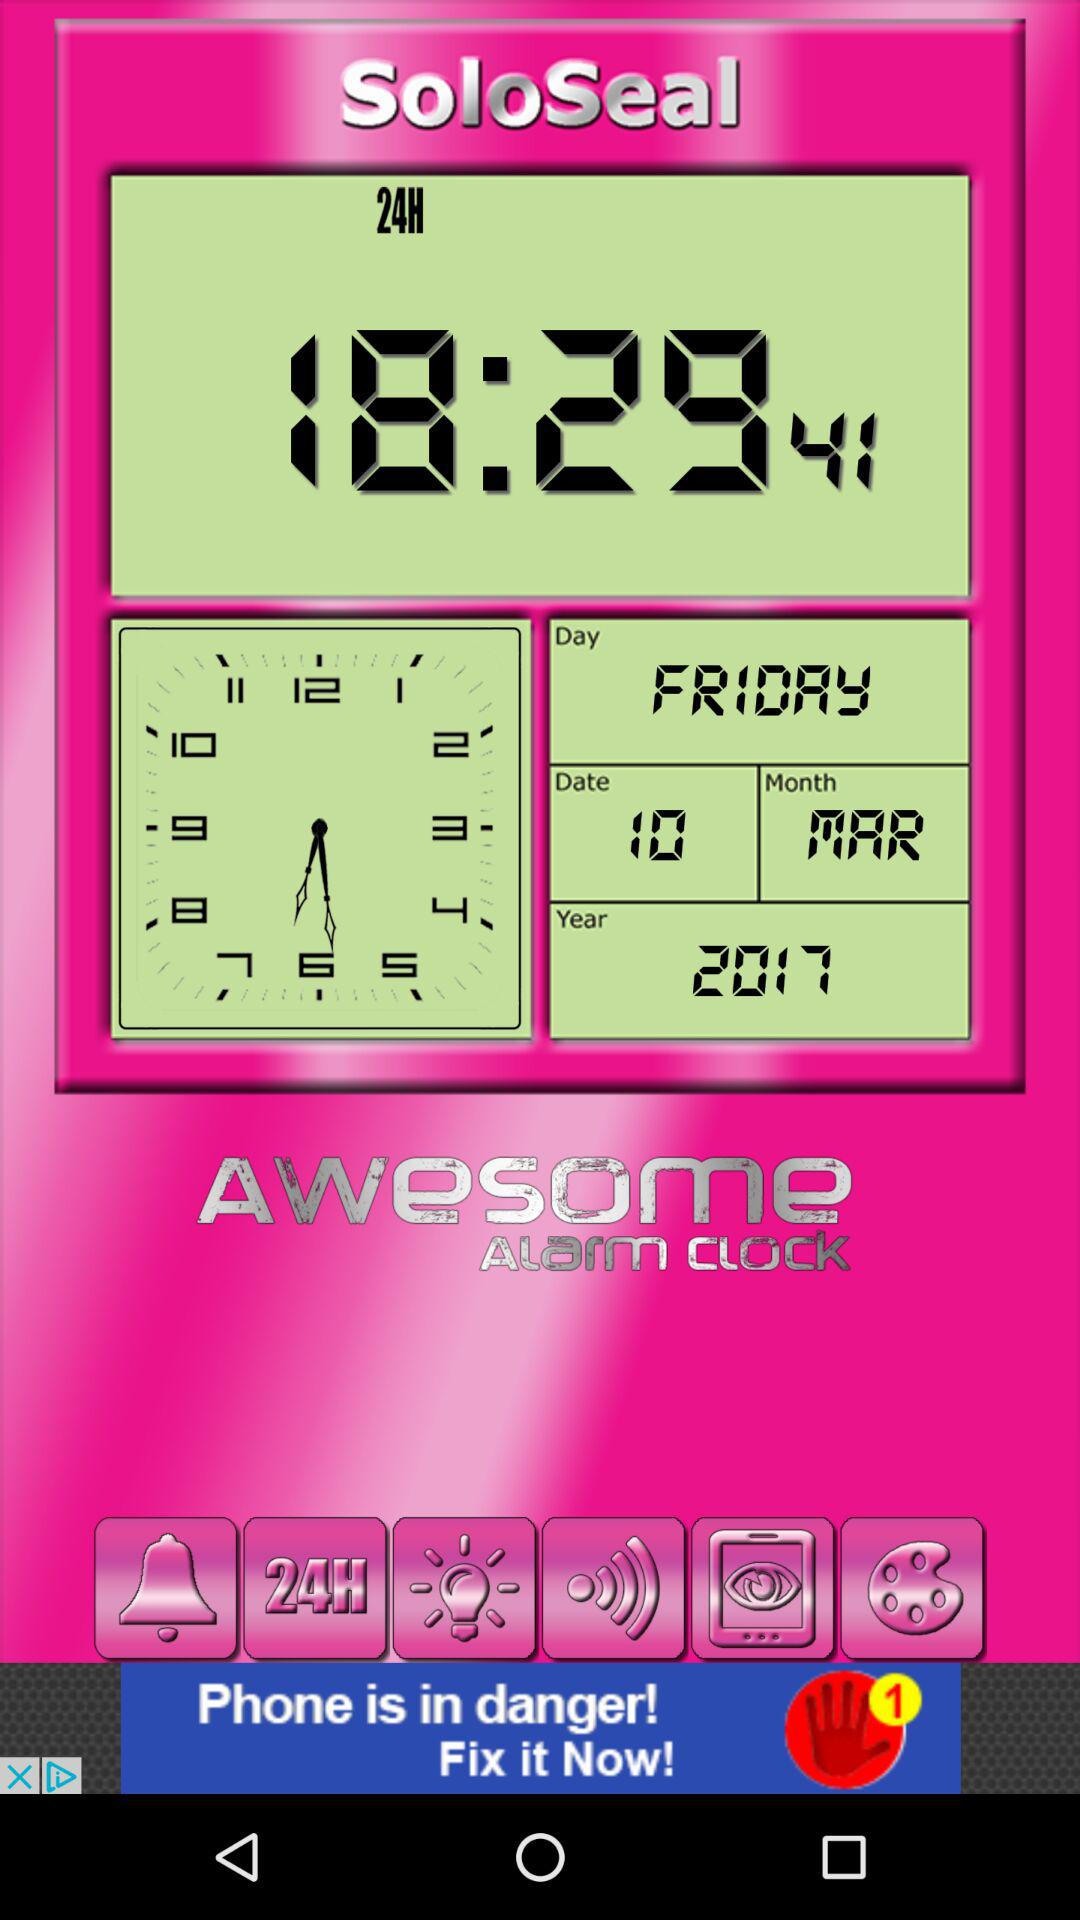What is the date? The date is Friday, March 10, 2017. 